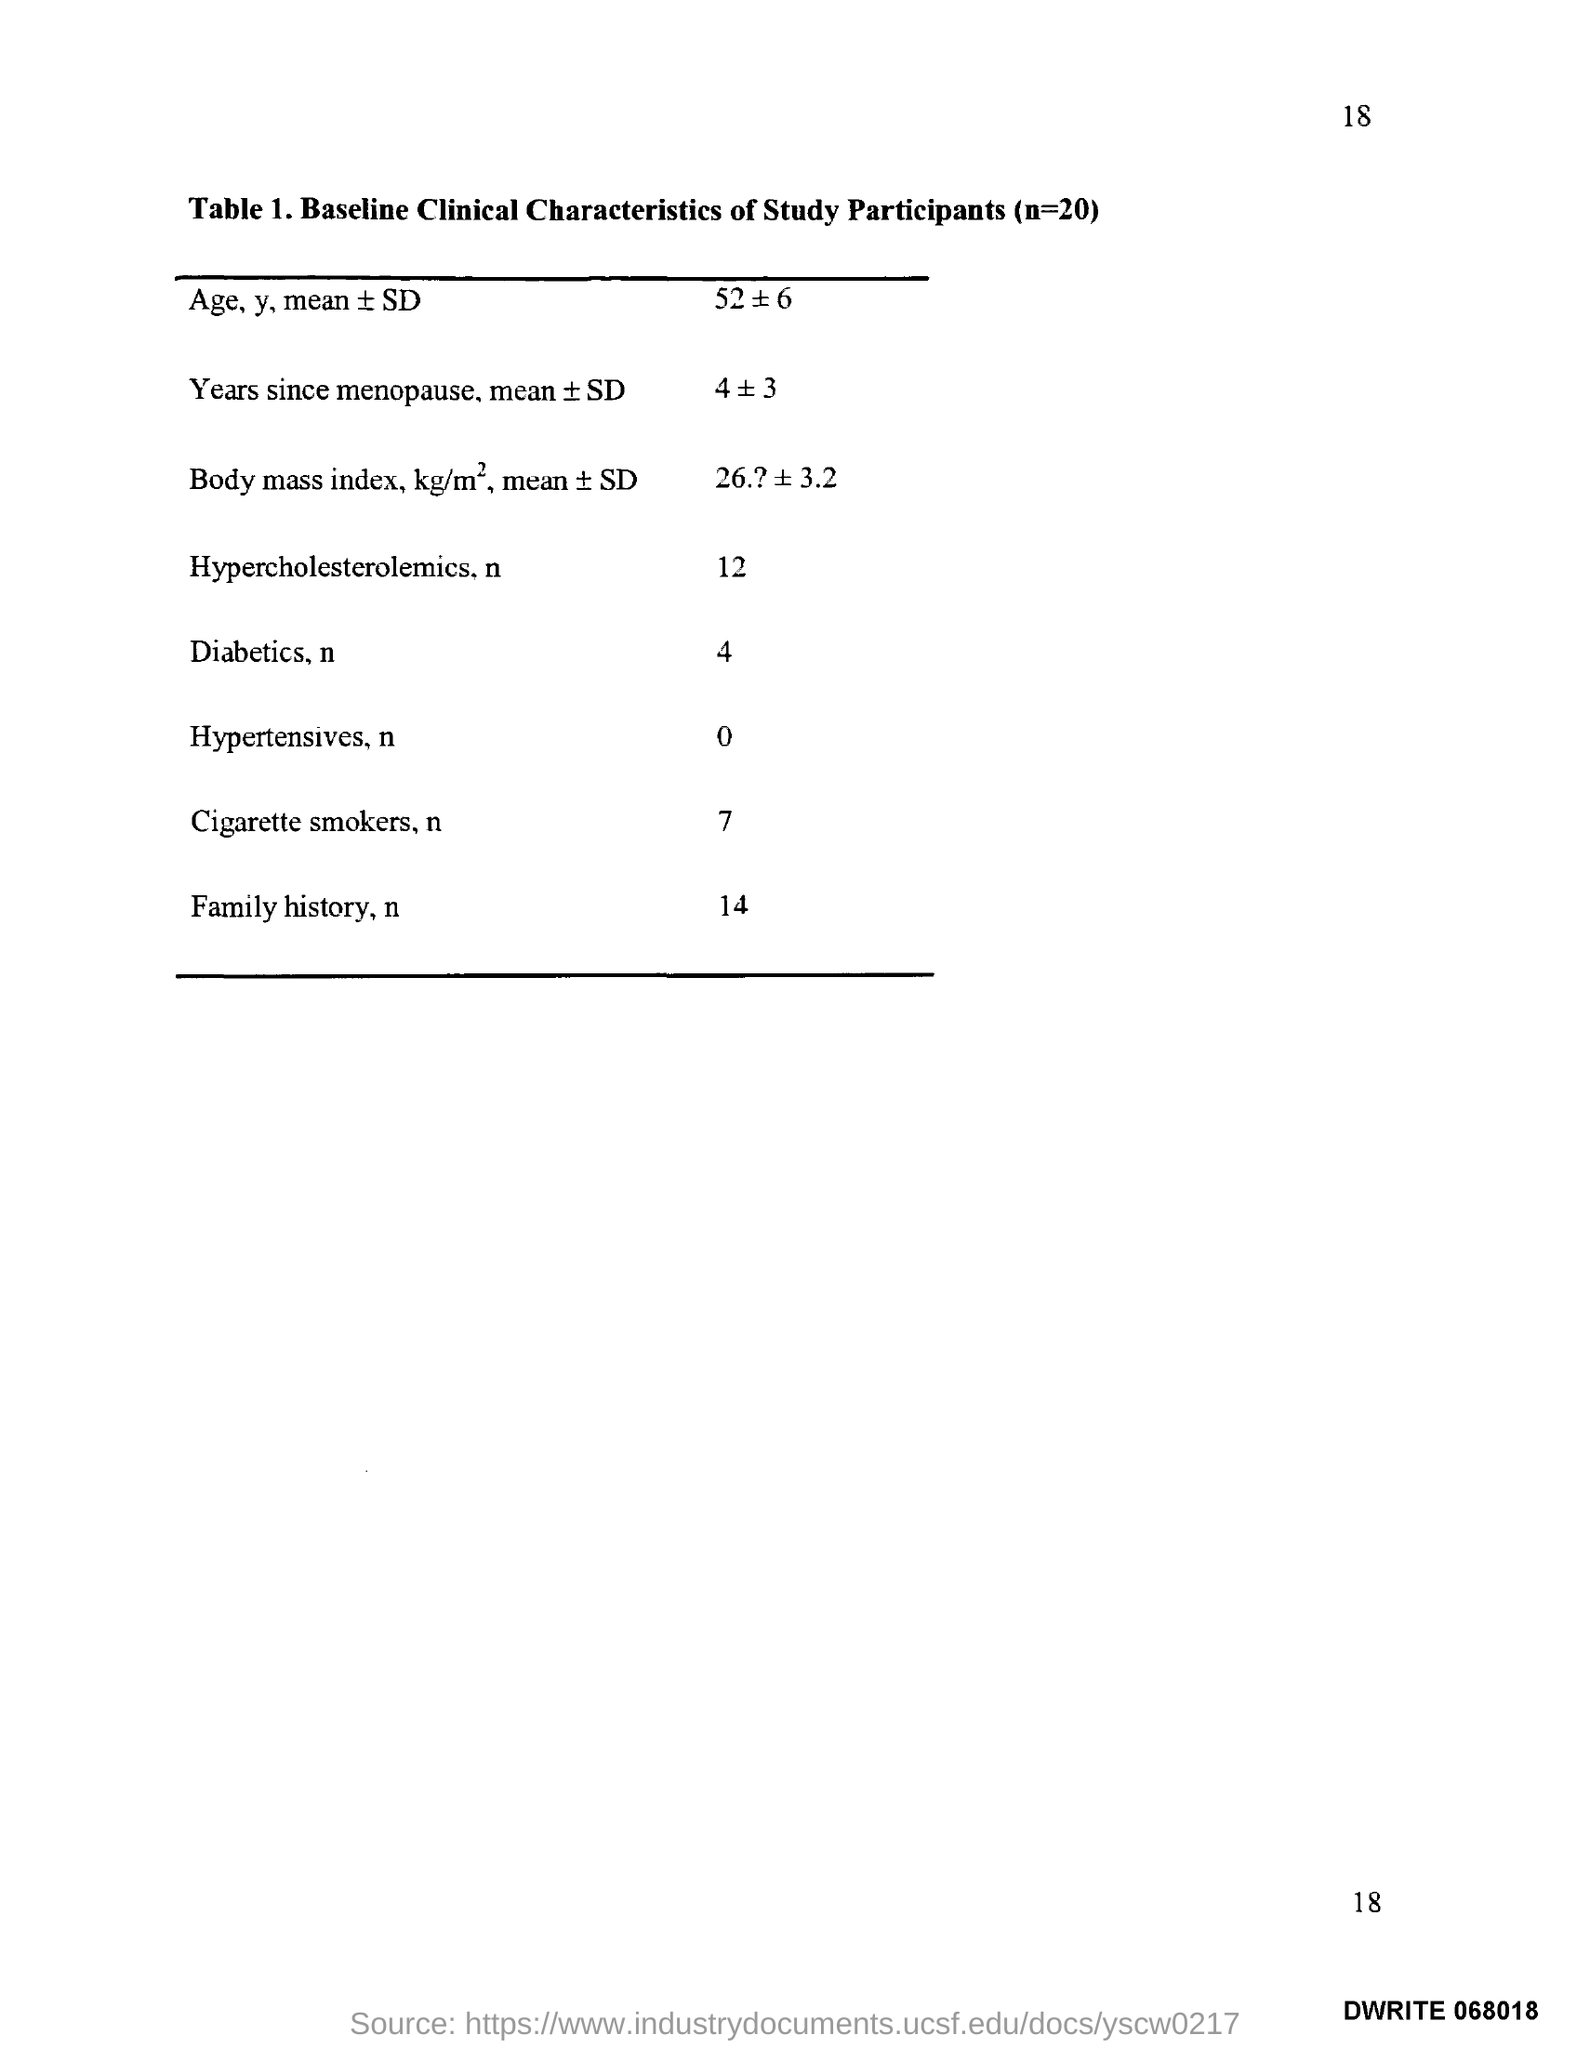What is the Page Number?
Your answer should be compact. 18. What is the number of Cigarette smokers?
Provide a succinct answer. 7. 